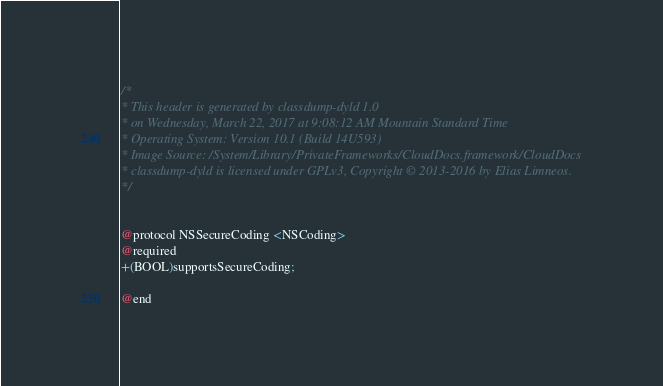<code> <loc_0><loc_0><loc_500><loc_500><_C_>/*
* This header is generated by classdump-dyld 1.0
* on Wednesday, March 22, 2017 at 9:08:12 AM Mountain Standard Time
* Operating System: Version 10.1 (Build 14U593)
* Image Source: /System/Library/PrivateFrameworks/CloudDocs.framework/CloudDocs
* classdump-dyld is licensed under GPLv3, Copyright © 2013-2016 by Elias Limneos.
*/


@protocol NSSecureCoding <NSCoding>
@required
+(BOOL)supportsSecureCoding;

@end

</code> 